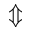<formula> <loc_0><loc_0><loc_500><loc_500>\Updownarrow</formula> 